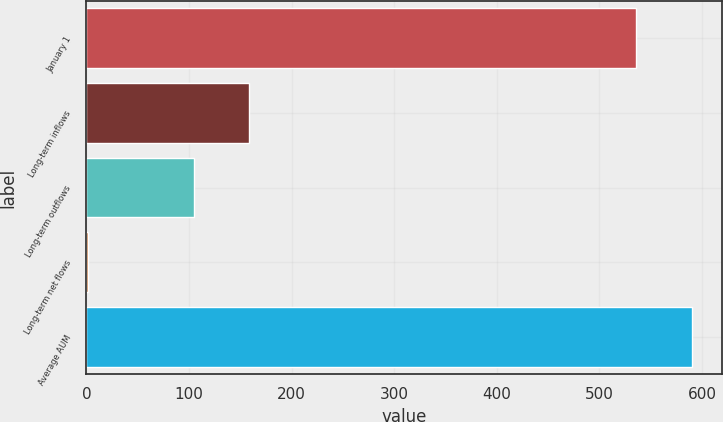Convert chart to OTSL. <chart><loc_0><loc_0><loc_500><loc_500><bar_chart><fcel>January 1<fcel>Long-term inflows<fcel>Long-term outflows<fcel>Long-term net flows<fcel>Average AUM<nl><fcel>535.7<fcel>158.73<fcel>104.6<fcel>1.7<fcel>589.83<nl></chart> 